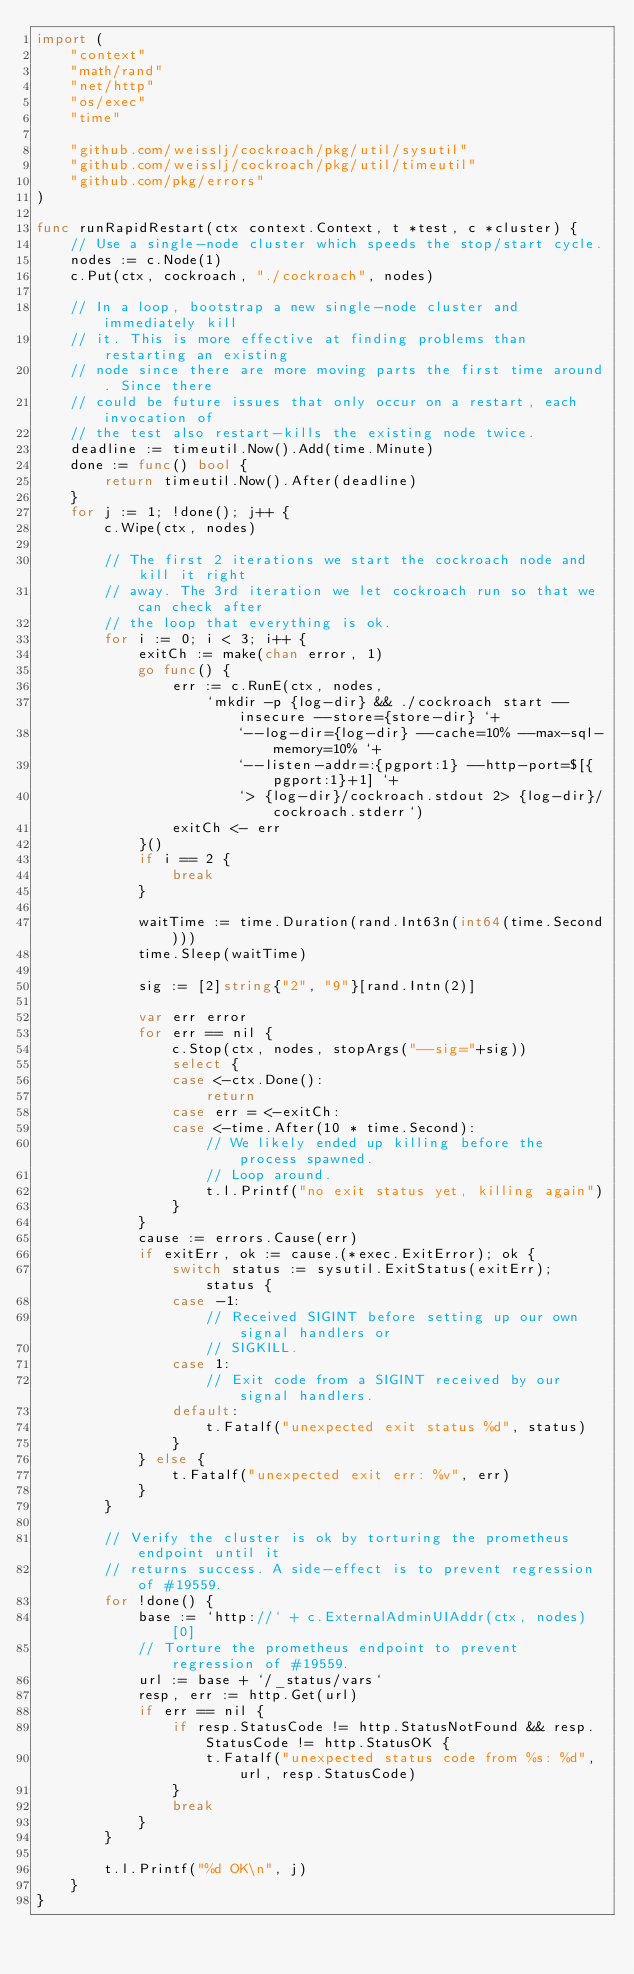<code> <loc_0><loc_0><loc_500><loc_500><_Go_>import (
	"context"
	"math/rand"
	"net/http"
	"os/exec"
	"time"

	"github.com/weisslj/cockroach/pkg/util/sysutil"
	"github.com/weisslj/cockroach/pkg/util/timeutil"
	"github.com/pkg/errors"
)

func runRapidRestart(ctx context.Context, t *test, c *cluster) {
	// Use a single-node cluster which speeds the stop/start cycle.
	nodes := c.Node(1)
	c.Put(ctx, cockroach, "./cockroach", nodes)

	// In a loop, bootstrap a new single-node cluster and immediately kill
	// it. This is more effective at finding problems than restarting an existing
	// node since there are more moving parts the first time around. Since there
	// could be future issues that only occur on a restart, each invocation of
	// the test also restart-kills the existing node twice.
	deadline := timeutil.Now().Add(time.Minute)
	done := func() bool {
		return timeutil.Now().After(deadline)
	}
	for j := 1; !done(); j++ {
		c.Wipe(ctx, nodes)

		// The first 2 iterations we start the cockroach node and kill it right
		// away. The 3rd iteration we let cockroach run so that we can check after
		// the loop that everything is ok.
		for i := 0; i < 3; i++ {
			exitCh := make(chan error, 1)
			go func() {
				err := c.RunE(ctx, nodes,
					`mkdir -p {log-dir} && ./cockroach start --insecure --store={store-dir} `+
						`--log-dir={log-dir} --cache=10% --max-sql-memory=10% `+
						`--listen-addr=:{pgport:1} --http-port=$[{pgport:1}+1] `+
						`> {log-dir}/cockroach.stdout 2> {log-dir}/cockroach.stderr`)
				exitCh <- err
			}()
			if i == 2 {
				break
			}

			waitTime := time.Duration(rand.Int63n(int64(time.Second)))
			time.Sleep(waitTime)

			sig := [2]string{"2", "9"}[rand.Intn(2)]

			var err error
			for err == nil {
				c.Stop(ctx, nodes, stopArgs("--sig="+sig))
				select {
				case <-ctx.Done():
					return
				case err = <-exitCh:
				case <-time.After(10 * time.Second):
					// We likely ended up killing before the process spawned.
					// Loop around.
					t.l.Printf("no exit status yet, killing again")
				}
			}
			cause := errors.Cause(err)
			if exitErr, ok := cause.(*exec.ExitError); ok {
				switch status := sysutil.ExitStatus(exitErr); status {
				case -1:
					// Received SIGINT before setting up our own signal handlers or
					// SIGKILL.
				case 1:
					// Exit code from a SIGINT received by our signal handlers.
				default:
					t.Fatalf("unexpected exit status %d", status)
				}
			} else {
				t.Fatalf("unexpected exit err: %v", err)
			}
		}

		// Verify the cluster is ok by torturing the prometheus endpoint until it
		// returns success. A side-effect is to prevent regression of #19559.
		for !done() {
			base := `http://` + c.ExternalAdminUIAddr(ctx, nodes)[0]
			// Torture the prometheus endpoint to prevent regression of #19559.
			url := base + `/_status/vars`
			resp, err := http.Get(url)
			if err == nil {
				if resp.StatusCode != http.StatusNotFound && resp.StatusCode != http.StatusOK {
					t.Fatalf("unexpected status code from %s: %d", url, resp.StatusCode)
				}
				break
			}
		}

		t.l.Printf("%d OK\n", j)
	}
}
</code> 